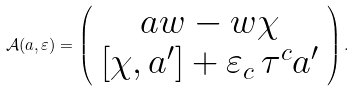Convert formula to latex. <formula><loc_0><loc_0><loc_500><loc_500>\mathcal { A } ( a , \varepsilon ) = \left ( \begin{array} { c } a w - w \chi \\ \left [ \chi , a ^ { \prime } \right ] + \varepsilon _ { c } \, \tau ^ { c } a ^ { \prime } \end{array} \right ) .</formula> 